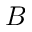<formula> <loc_0><loc_0><loc_500><loc_500>B</formula> 